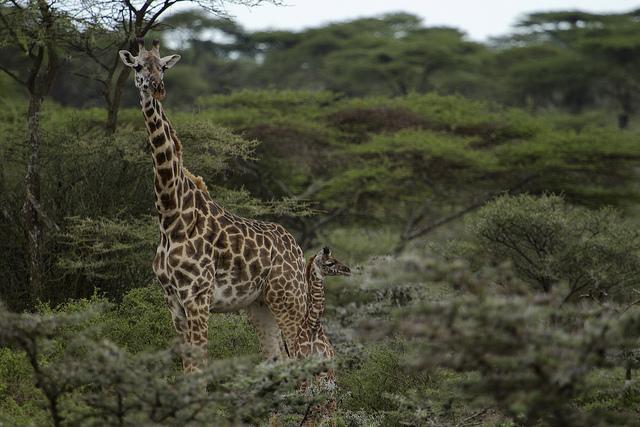How many giraffes are there?
Give a very brief answer. 1. How many giraffes are in the photo?
Give a very brief answer. 2. 